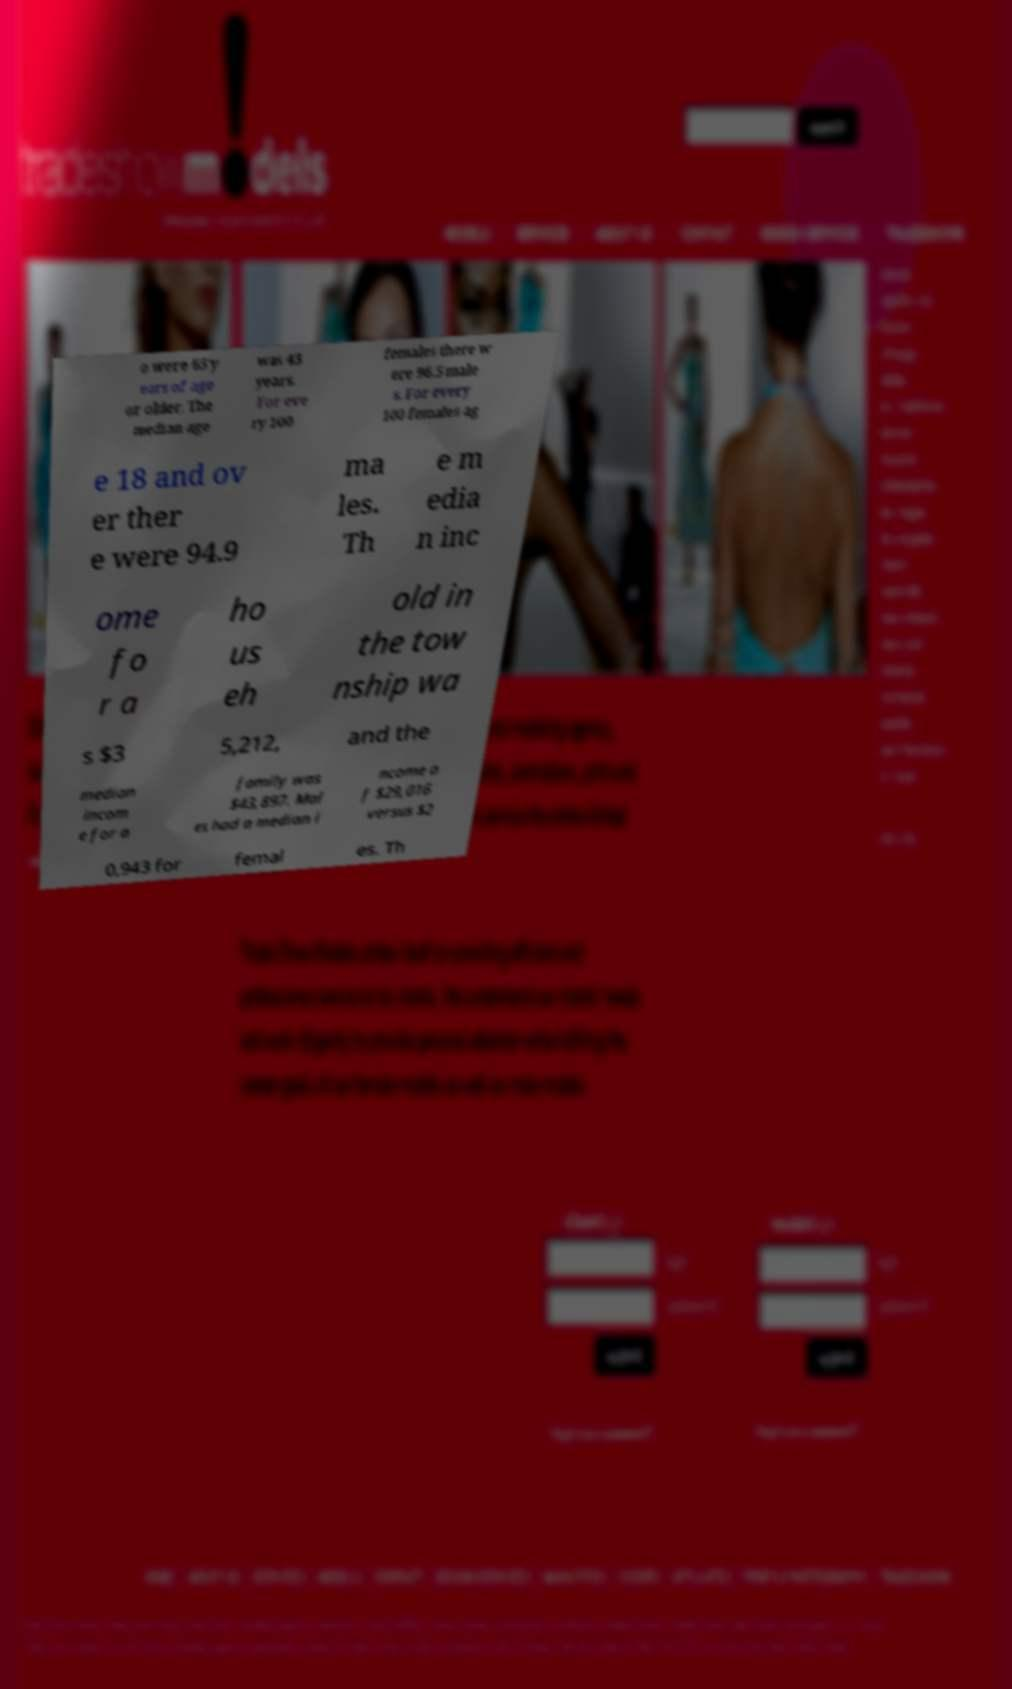There's text embedded in this image that I need extracted. Can you transcribe it verbatim? o were 65 y ears of age or older. The median age was 43 years. For eve ry 100 females there w ere 96.5 male s. For every 100 females ag e 18 and ov er ther e were 94.9 ma les. Th e m edia n inc ome fo r a ho us eh old in the tow nship wa s $3 5,212, and the median incom e for a family was $43,897. Mal es had a median i ncome o f $29,016 versus $2 0,943 for femal es. Th 